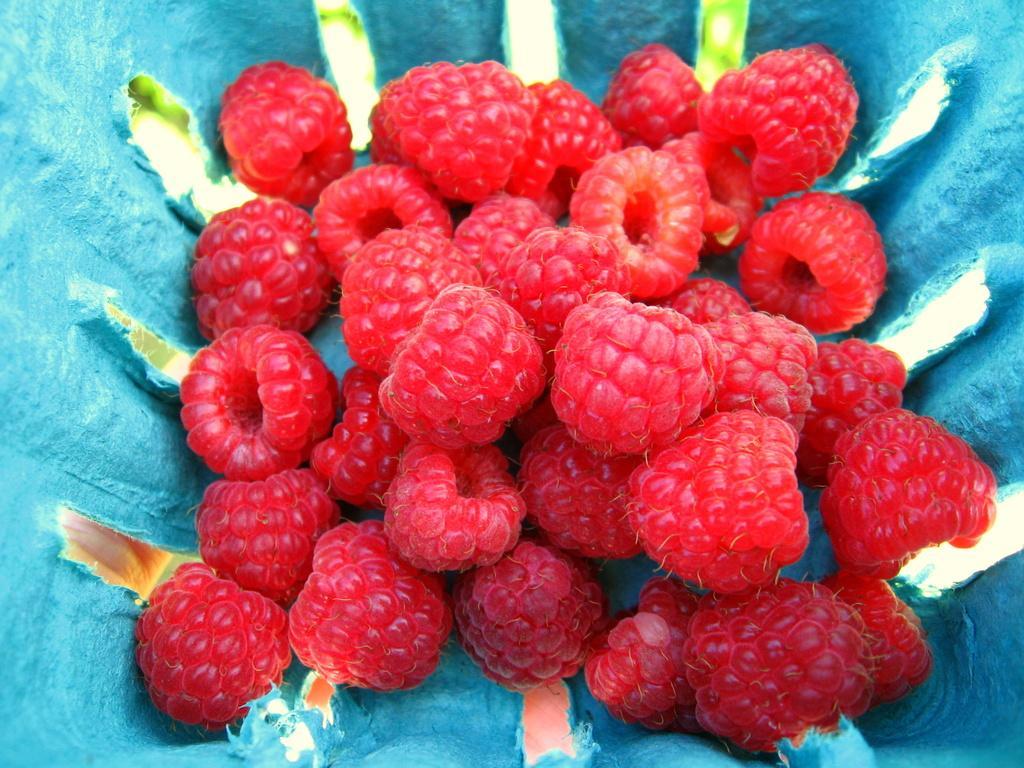Please provide a concise description of this image. In this image we can see the raspberries in a cloth. 